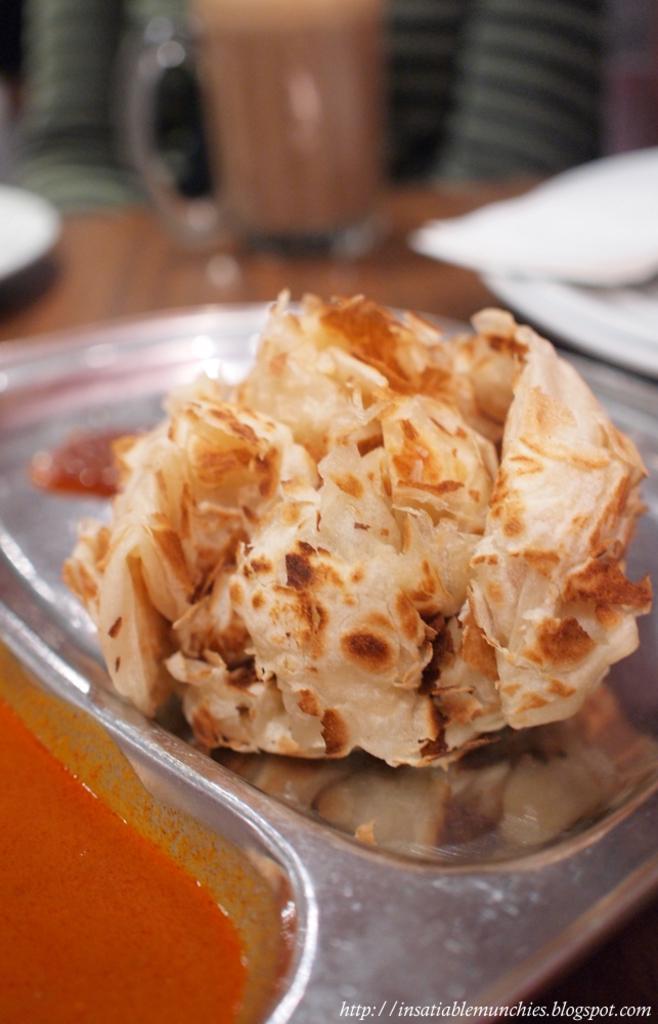Describe this image in one or two sentences. On a steel plate there is a chur chur naan and a curry at the left. The background is blurred. 